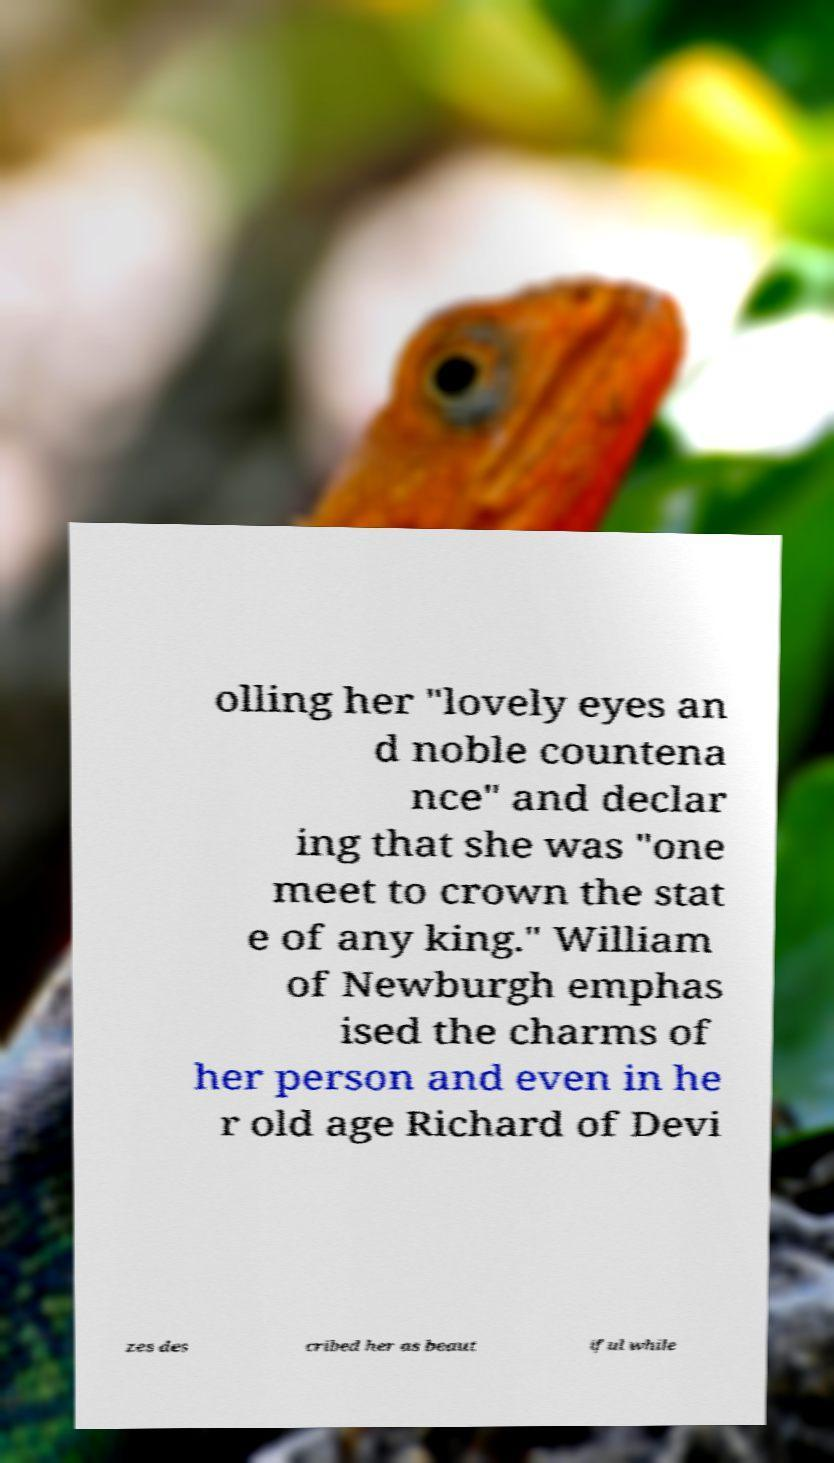Can you accurately transcribe the text from the provided image for me? olling her "lovely eyes an d noble countena nce" and declar ing that she was "one meet to crown the stat e of any king." William of Newburgh emphas ised the charms of her person and even in he r old age Richard of Devi zes des cribed her as beaut iful while 